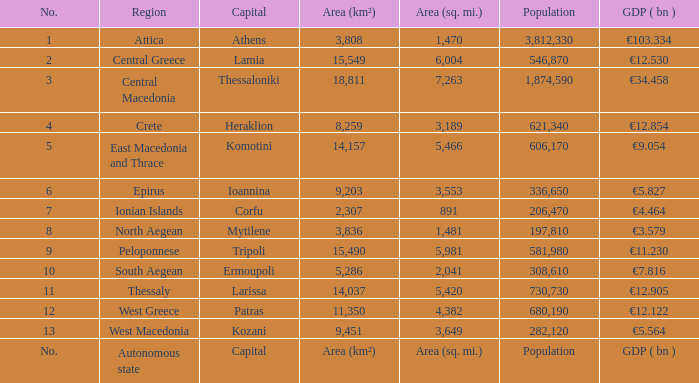What is the gdp ( bn ) where capital is capital? GDP ( bn ). 